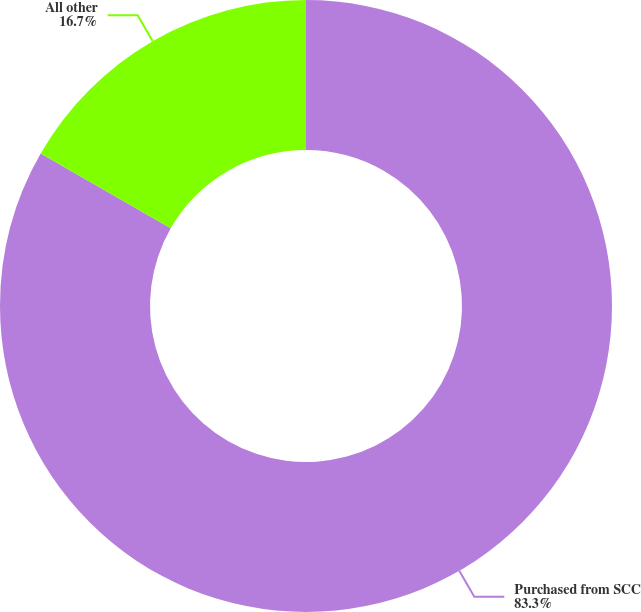Convert chart. <chart><loc_0><loc_0><loc_500><loc_500><pie_chart><fcel>Purchased from SCC<fcel>All other<nl><fcel>83.3%<fcel>16.7%<nl></chart> 